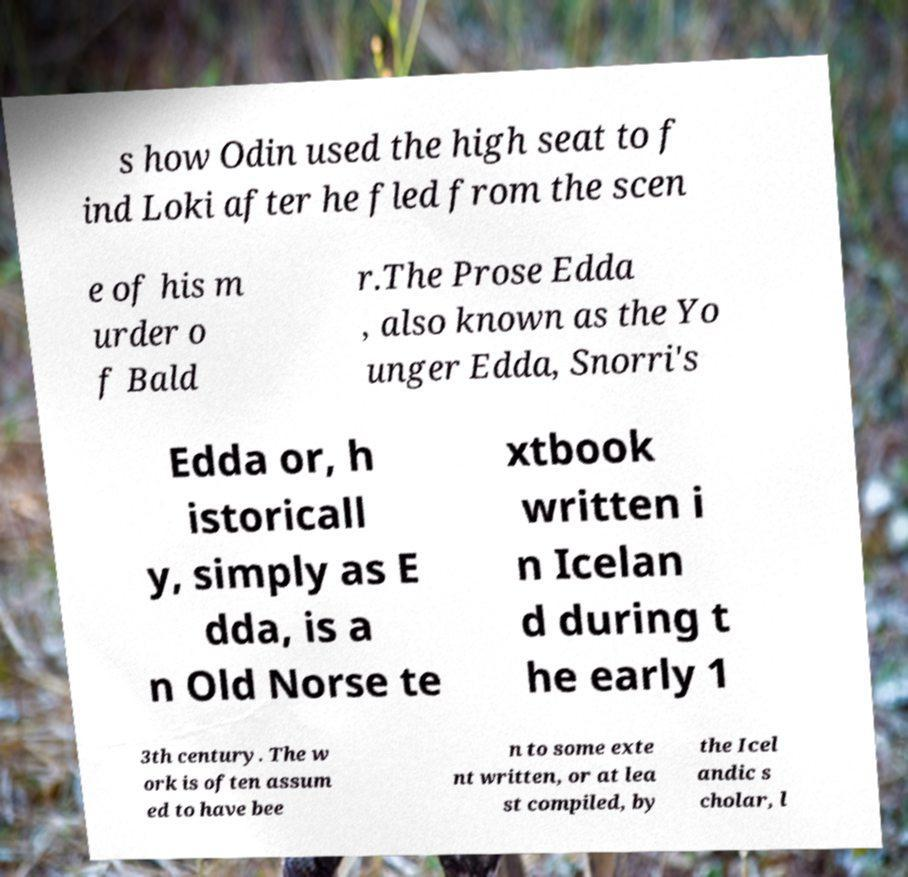Could you extract and type out the text from this image? s how Odin used the high seat to f ind Loki after he fled from the scen e of his m urder o f Bald r.The Prose Edda , also known as the Yo unger Edda, Snorri's Edda or, h istoricall y, simply as E dda, is a n Old Norse te xtbook written i n Icelan d during t he early 1 3th century. The w ork is often assum ed to have bee n to some exte nt written, or at lea st compiled, by the Icel andic s cholar, l 